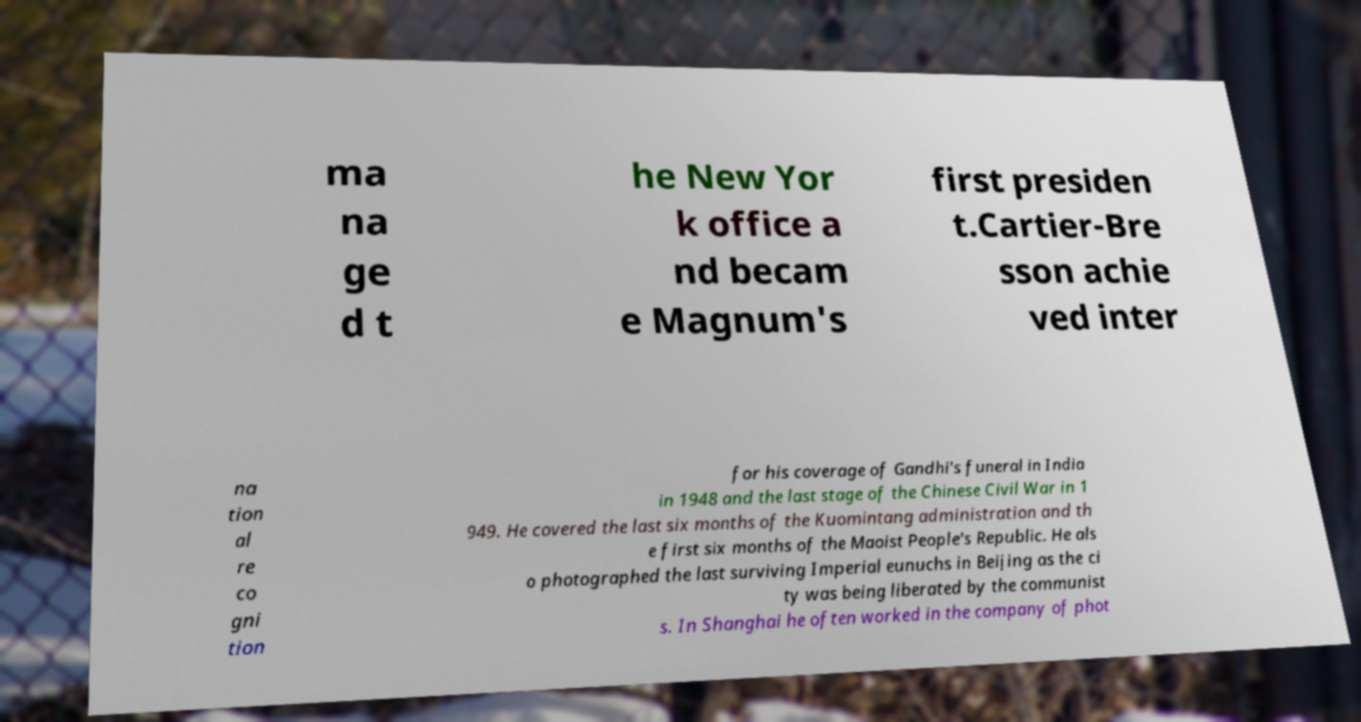There's text embedded in this image that I need extracted. Can you transcribe it verbatim? ma na ge d t he New Yor k office a nd becam e Magnum's first presiden t.Cartier-Bre sson achie ved inter na tion al re co gni tion for his coverage of Gandhi's funeral in India in 1948 and the last stage of the Chinese Civil War in 1 949. He covered the last six months of the Kuomintang administration and th e first six months of the Maoist People's Republic. He als o photographed the last surviving Imperial eunuchs in Beijing as the ci ty was being liberated by the communist s. In Shanghai he often worked in the company of phot 